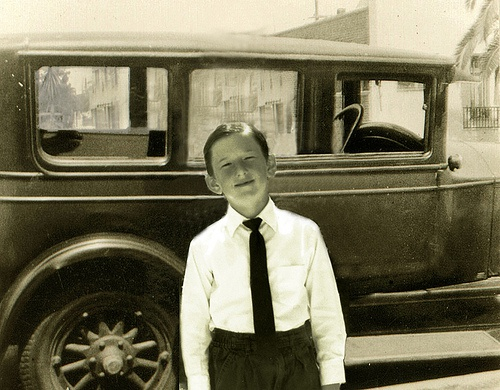Describe the objects in this image and their specific colors. I can see car in beige, black, darkgreen, and tan tones, people in beige, black, and olive tones, and tie in beige, black, darkgreen, and olive tones in this image. 